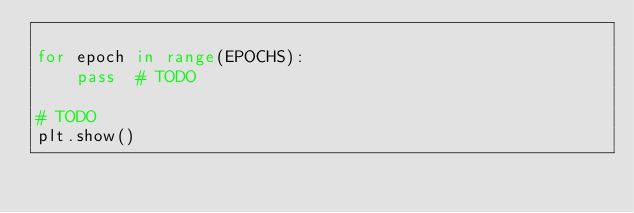<code> <loc_0><loc_0><loc_500><loc_500><_Python_>
for epoch in range(EPOCHS):
    pass  # TODO

# TODO
plt.show()
</code> 